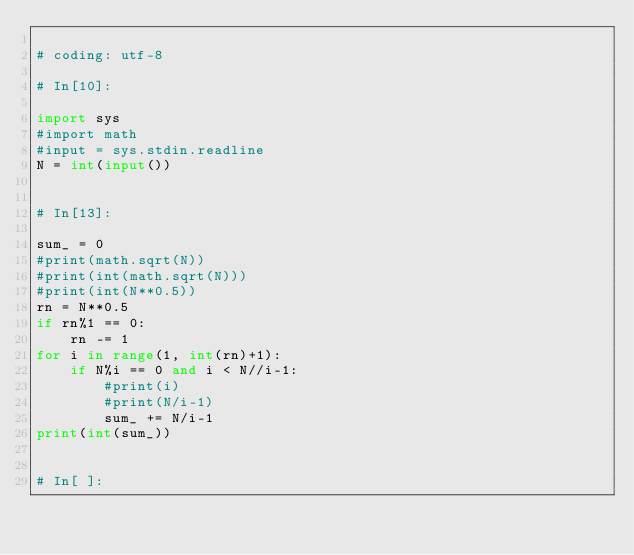<code> <loc_0><loc_0><loc_500><loc_500><_Python_>
# coding: utf-8

# In[10]:

import sys
#import math
#input = sys.stdin.readline
N = int(input())


# In[13]:

sum_ = 0
#print(math.sqrt(N))
#print(int(math.sqrt(N)))
#print(int(N**0.5))
rn = N**0.5
if rn%1 == 0:
    rn -= 1
for i in range(1, int(rn)+1):
    if N%i == 0 and i < N//i-1:
        #print(i)
        #print(N/i-1)
        sum_ += N/i-1
print(int(sum_))


# In[ ]:



</code> 